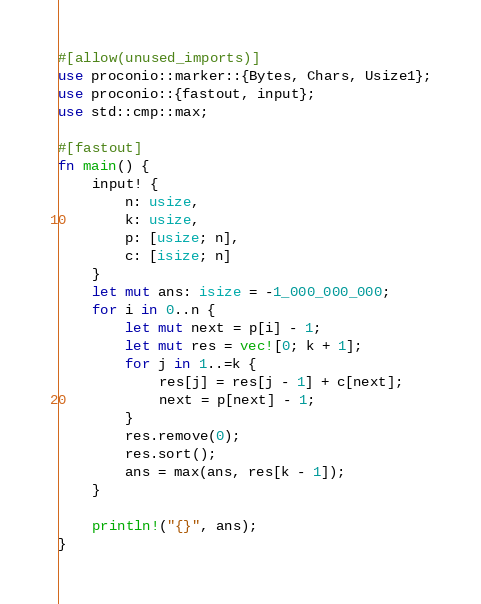<code> <loc_0><loc_0><loc_500><loc_500><_Rust_>#[allow(unused_imports)]
use proconio::marker::{Bytes, Chars, Usize1};
use proconio::{fastout, input};
use std::cmp::max;

#[fastout]
fn main() {
    input! {
        n: usize,
        k: usize,
        p: [usize; n],
        c: [isize; n]
    }
    let mut ans: isize = -1_000_000_000;
    for i in 0..n {
        let mut next = p[i] - 1;
        let mut res = vec![0; k + 1];
        for j in 1..=k {
            res[j] = res[j - 1] + c[next];
            next = p[next] - 1;
        }
        res.remove(0);
        res.sort();
        ans = max(ans, res[k - 1]);
    }

    println!("{}", ans);
}
</code> 